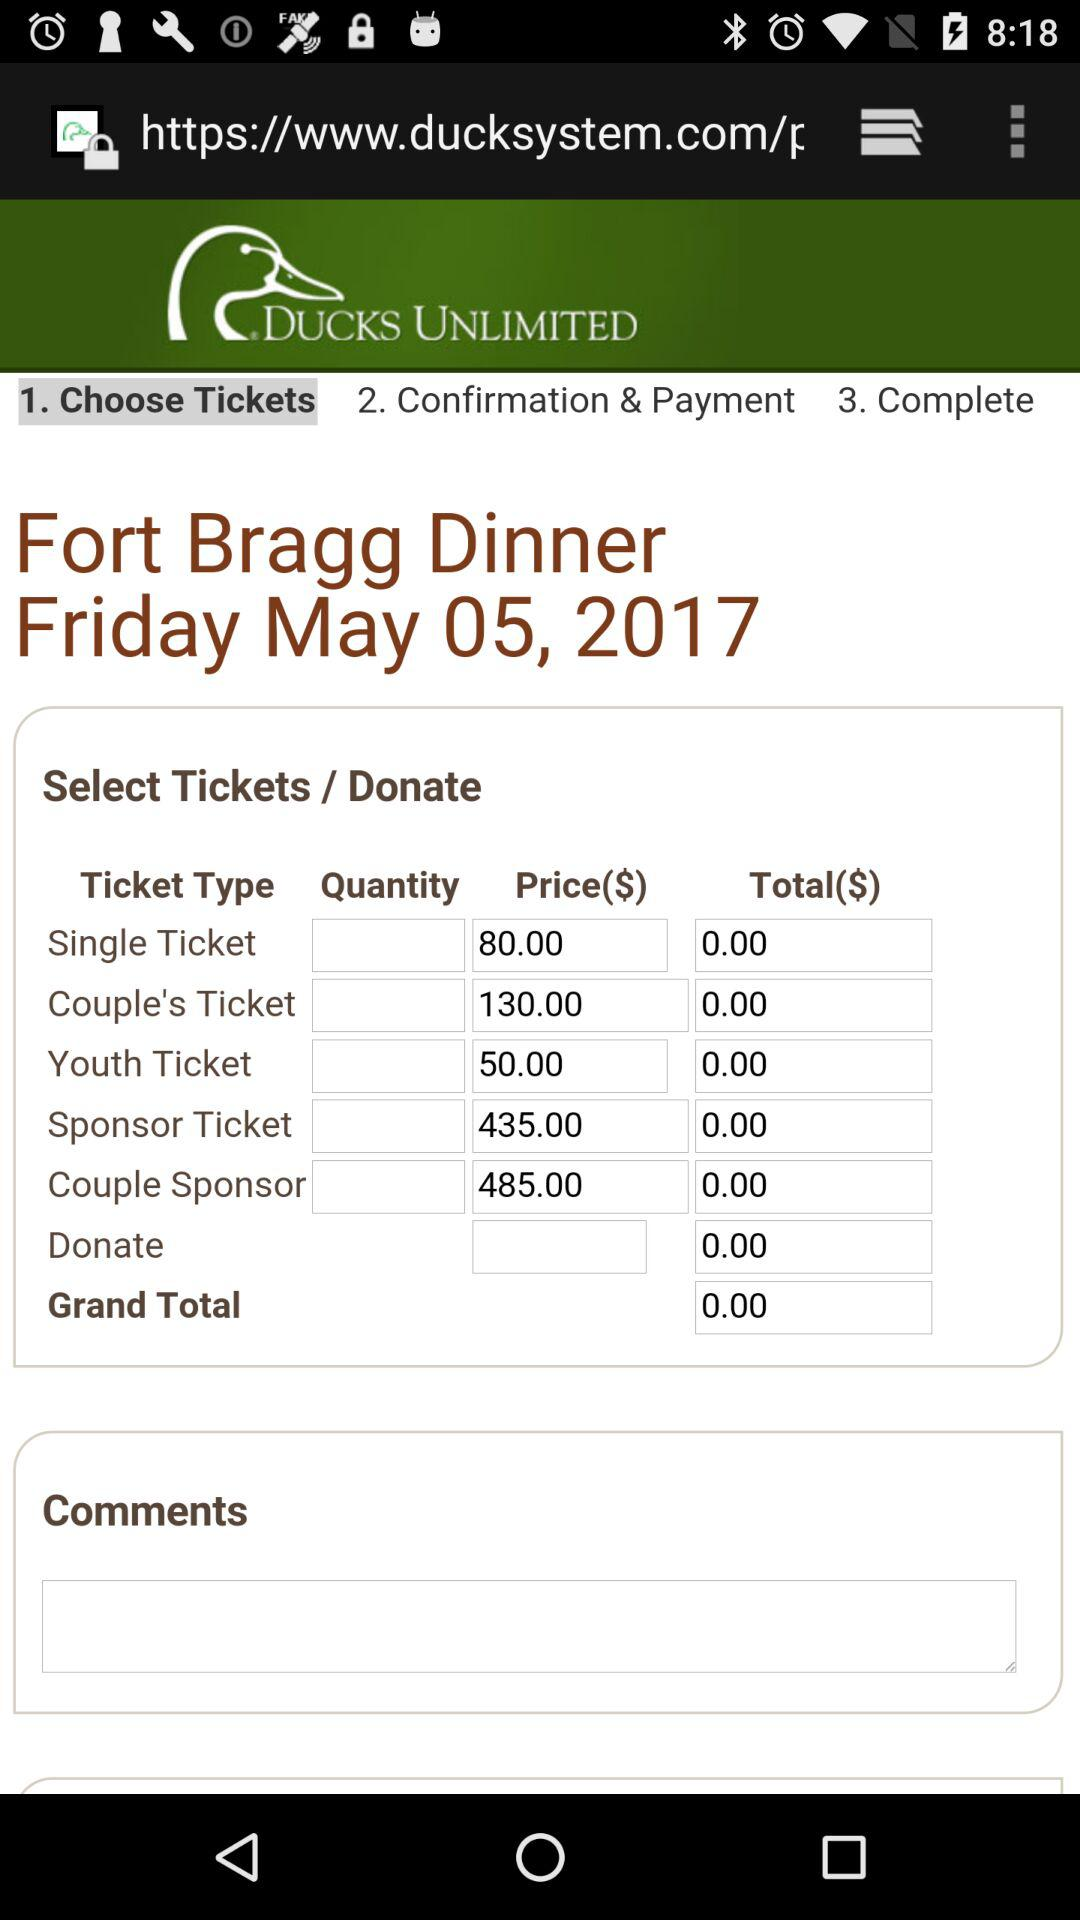What is the price for a "Sponsor Ticket"? The price is $435. 